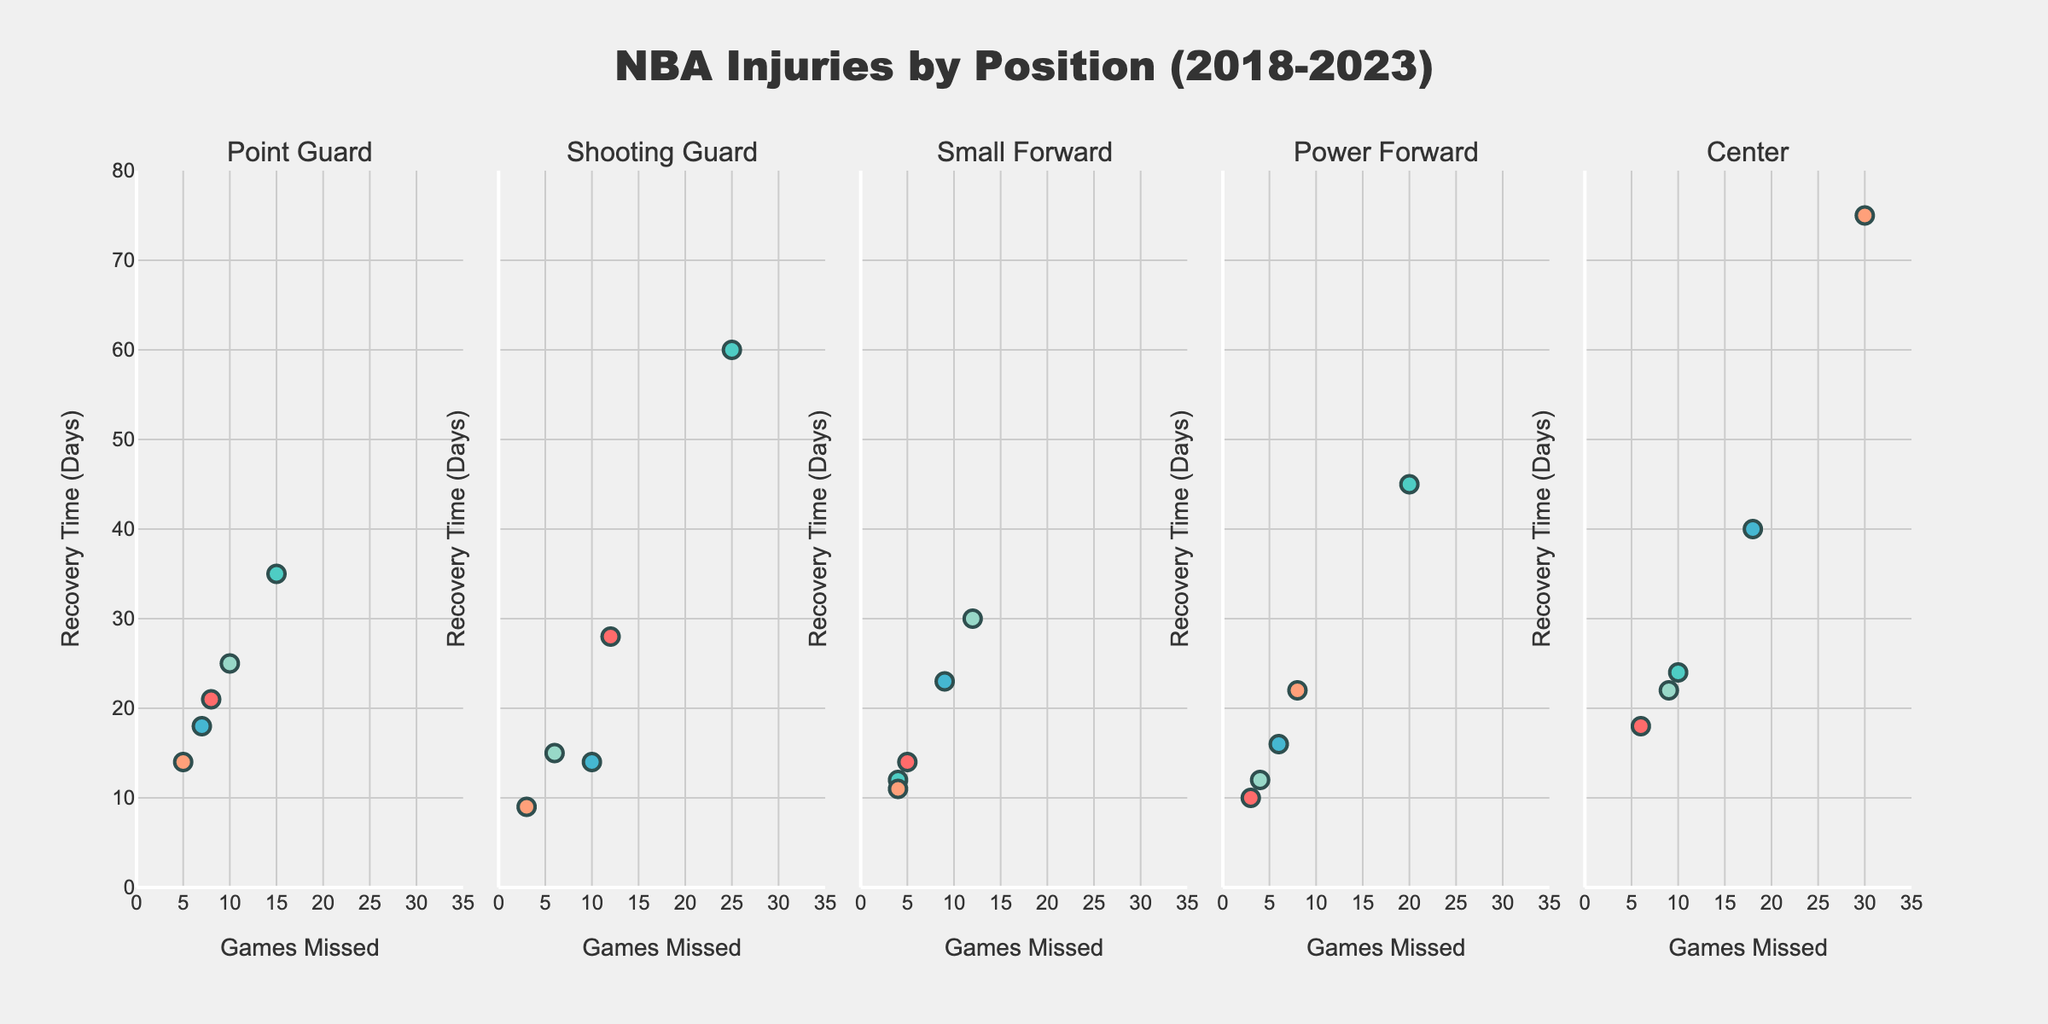Which position has the instance with the highest number of games missed? By examining each subplot, the Center position subplot shows the highest number of games missed with 30 games during the 2021-22 season
Answer: Center Which injury had the longest recovery time? Looking at the y-axes across all subplots, the longest recovery time is for the Center subplot with 75 days during the 2021-22 season for an ankle fracture injury
Answer: Ankle Fracture What is the primary color used for the Point Guard subplot? The primary color in the Point Guard subplot is red, as observed from the colored markers representing different seasons
Answer: Red How many injuries had a recovery time of exactly 14 days? By reviewing all subplots and focusing on the y-axis value of 14 days, we see two cases: Point Guard with a thumb sprain in 2021-22 and Shooting Guard with COVID-19 protocol in 2020-21
Answer: 2 Which season had the most injuries for the Shooting Guard position? The subplot for the Shooting Guard shows that the 2019-20 season had three injuries, which is the highest count compared to other seasons
Answer: 2019-20 How many Center injuries had a recovery time greater than 30 days? By scanning the Center subplot and identifying data points above the 30-day mark on the y-axis, we find two such injuries: an ankle fracture in 2021-22 and a knee sprain in 2020-21
Answer: 2 Which injury type caused the longest recovery time in the 2020-21 season? Within the subplots for all positions, the Center subplot shows a knee sprain with a recovery time of 40 days, the longest in that season
Answer: Knee Sprain Compare the recovery time distribution for Point Guard and Shooting Guard. Which position has a wider range? Point Guard has a range from 14 to 35 days and Shooting Guard from 9 to 60 days. The Shooting Guard position has a wider distribution of recovery times
Answer: Shooting Guard What’s the average recovery time for injuries in the Power Forward position for the 2020-21 season? The Power Forward subplot shows injuries with recovery times of 10, 16, and 22 days in the 2020-21 season. The average is (10+16+22)/3 = 16
Answer: 16 Which position had the least number of injuries recorded in the figure? The Small Forward position has fewer data points compared to other subplots, indicating the least number of injuries recorded
Answer: Small Forward 